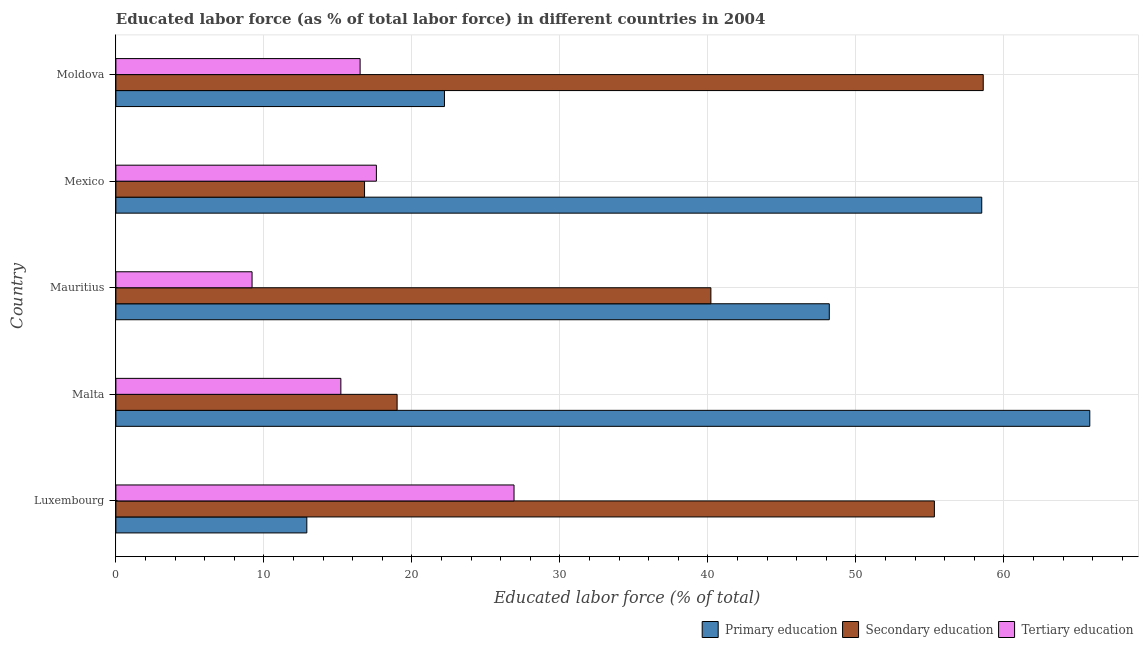How many different coloured bars are there?
Your answer should be very brief. 3. How many groups of bars are there?
Make the answer very short. 5. Are the number of bars per tick equal to the number of legend labels?
Your answer should be compact. Yes. Are the number of bars on each tick of the Y-axis equal?
Your answer should be compact. Yes. How many bars are there on the 4th tick from the top?
Keep it short and to the point. 3. What is the label of the 1st group of bars from the top?
Provide a succinct answer. Moldova. In how many cases, is the number of bars for a given country not equal to the number of legend labels?
Offer a terse response. 0. What is the percentage of labor force who received primary education in Luxembourg?
Offer a very short reply. 12.9. Across all countries, what is the maximum percentage of labor force who received tertiary education?
Offer a very short reply. 26.9. Across all countries, what is the minimum percentage of labor force who received secondary education?
Make the answer very short. 16.8. In which country was the percentage of labor force who received primary education maximum?
Provide a short and direct response. Malta. In which country was the percentage of labor force who received secondary education minimum?
Offer a very short reply. Mexico. What is the total percentage of labor force who received tertiary education in the graph?
Your answer should be very brief. 85.4. What is the difference between the percentage of labor force who received primary education in Mexico and that in Moldova?
Your answer should be very brief. 36.3. What is the difference between the percentage of labor force who received primary education in Moldova and the percentage of labor force who received tertiary education in Malta?
Your answer should be compact. 7. What is the average percentage of labor force who received secondary education per country?
Give a very brief answer. 37.98. In how many countries, is the percentage of labor force who received secondary education greater than 6 %?
Provide a succinct answer. 5. What is the ratio of the percentage of labor force who received secondary education in Malta to that in Mauritius?
Offer a terse response. 0.47. Is the difference between the percentage of labor force who received secondary education in Luxembourg and Malta greater than the difference between the percentage of labor force who received primary education in Luxembourg and Malta?
Ensure brevity in your answer.  Yes. What is the difference between the highest and the second highest percentage of labor force who received primary education?
Ensure brevity in your answer.  7.3. What is the difference between the highest and the lowest percentage of labor force who received primary education?
Give a very brief answer. 52.9. What does the 1st bar from the top in Mauritius represents?
Your answer should be compact. Tertiary education. What does the 3rd bar from the bottom in Mauritius represents?
Offer a terse response. Tertiary education. Are all the bars in the graph horizontal?
Offer a terse response. Yes. Are the values on the major ticks of X-axis written in scientific E-notation?
Offer a terse response. No. Does the graph contain any zero values?
Ensure brevity in your answer.  No. How many legend labels are there?
Ensure brevity in your answer.  3. What is the title of the graph?
Your response must be concise. Educated labor force (as % of total labor force) in different countries in 2004. What is the label or title of the X-axis?
Make the answer very short. Educated labor force (% of total). What is the Educated labor force (% of total) in Primary education in Luxembourg?
Offer a terse response. 12.9. What is the Educated labor force (% of total) in Secondary education in Luxembourg?
Offer a very short reply. 55.3. What is the Educated labor force (% of total) of Tertiary education in Luxembourg?
Offer a very short reply. 26.9. What is the Educated labor force (% of total) of Primary education in Malta?
Keep it short and to the point. 65.8. What is the Educated labor force (% of total) in Secondary education in Malta?
Your answer should be compact. 19. What is the Educated labor force (% of total) of Tertiary education in Malta?
Provide a succinct answer. 15.2. What is the Educated labor force (% of total) in Primary education in Mauritius?
Offer a terse response. 48.2. What is the Educated labor force (% of total) in Secondary education in Mauritius?
Provide a short and direct response. 40.2. What is the Educated labor force (% of total) in Tertiary education in Mauritius?
Keep it short and to the point. 9.2. What is the Educated labor force (% of total) in Primary education in Mexico?
Your response must be concise. 58.5. What is the Educated labor force (% of total) in Secondary education in Mexico?
Provide a succinct answer. 16.8. What is the Educated labor force (% of total) in Tertiary education in Mexico?
Your response must be concise. 17.6. What is the Educated labor force (% of total) of Primary education in Moldova?
Your answer should be very brief. 22.2. What is the Educated labor force (% of total) of Secondary education in Moldova?
Ensure brevity in your answer.  58.6. What is the Educated labor force (% of total) of Tertiary education in Moldova?
Provide a short and direct response. 16.5. Across all countries, what is the maximum Educated labor force (% of total) of Primary education?
Make the answer very short. 65.8. Across all countries, what is the maximum Educated labor force (% of total) in Secondary education?
Keep it short and to the point. 58.6. Across all countries, what is the maximum Educated labor force (% of total) in Tertiary education?
Keep it short and to the point. 26.9. Across all countries, what is the minimum Educated labor force (% of total) of Primary education?
Provide a short and direct response. 12.9. Across all countries, what is the minimum Educated labor force (% of total) in Secondary education?
Your answer should be very brief. 16.8. Across all countries, what is the minimum Educated labor force (% of total) in Tertiary education?
Provide a succinct answer. 9.2. What is the total Educated labor force (% of total) of Primary education in the graph?
Offer a very short reply. 207.6. What is the total Educated labor force (% of total) of Secondary education in the graph?
Offer a very short reply. 189.9. What is the total Educated labor force (% of total) of Tertiary education in the graph?
Give a very brief answer. 85.4. What is the difference between the Educated labor force (% of total) of Primary education in Luxembourg and that in Malta?
Give a very brief answer. -52.9. What is the difference between the Educated labor force (% of total) of Secondary education in Luxembourg and that in Malta?
Offer a terse response. 36.3. What is the difference between the Educated labor force (% of total) in Primary education in Luxembourg and that in Mauritius?
Offer a very short reply. -35.3. What is the difference between the Educated labor force (% of total) in Primary education in Luxembourg and that in Mexico?
Your answer should be very brief. -45.6. What is the difference between the Educated labor force (% of total) of Secondary education in Luxembourg and that in Mexico?
Make the answer very short. 38.5. What is the difference between the Educated labor force (% of total) in Tertiary education in Luxembourg and that in Mexico?
Provide a short and direct response. 9.3. What is the difference between the Educated labor force (% of total) of Secondary education in Luxembourg and that in Moldova?
Offer a terse response. -3.3. What is the difference between the Educated labor force (% of total) in Secondary education in Malta and that in Mauritius?
Your answer should be compact. -21.2. What is the difference between the Educated labor force (% of total) in Primary education in Malta and that in Mexico?
Keep it short and to the point. 7.3. What is the difference between the Educated labor force (% of total) in Primary education in Malta and that in Moldova?
Make the answer very short. 43.6. What is the difference between the Educated labor force (% of total) in Secondary education in Malta and that in Moldova?
Provide a short and direct response. -39.6. What is the difference between the Educated labor force (% of total) in Primary education in Mauritius and that in Mexico?
Provide a succinct answer. -10.3. What is the difference between the Educated labor force (% of total) of Secondary education in Mauritius and that in Mexico?
Your answer should be very brief. 23.4. What is the difference between the Educated labor force (% of total) in Tertiary education in Mauritius and that in Mexico?
Your response must be concise. -8.4. What is the difference between the Educated labor force (% of total) in Primary education in Mauritius and that in Moldova?
Provide a succinct answer. 26. What is the difference between the Educated labor force (% of total) of Secondary education in Mauritius and that in Moldova?
Ensure brevity in your answer.  -18.4. What is the difference between the Educated labor force (% of total) of Primary education in Mexico and that in Moldova?
Provide a succinct answer. 36.3. What is the difference between the Educated labor force (% of total) in Secondary education in Mexico and that in Moldova?
Your response must be concise. -41.8. What is the difference between the Educated labor force (% of total) of Primary education in Luxembourg and the Educated labor force (% of total) of Secondary education in Malta?
Provide a short and direct response. -6.1. What is the difference between the Educated labor force (% of total) in Secondary education in Luxembourg and the Educated labor force (% of total) in Tertiary education in Malta?
Give a very brief answer. 40.1. What is the difference between the Educated labor force (% of total) of Primary education in Luxembourg and the Educated labor force (% of total) of Secondary education in Mauritius?
Provide a short and direct response. -27.3. What is the difference between the Educated labor force (% of total) of Primary education in Luxembourg and the Educated labor force (% of total) of Tertiary education in Mauritius?
Ensure brevity in your answer.  3.7. What is the difference between the Educated labor force (% of total) of Secondary education in Luxembourg and the Educated labor force (% of total) of Tertiary education in Mauritius?
Keep it short and to the point. 46.1. What is the difference between the Educated labor force (% of total) in Primary education in Luxembourg and the Educated labor force (% of total) in Secondary education in Mexico?
Your response must be concise. -3.9. What is the difference between the Educated labor force (% of total) in Secondary education in Luxembourg and the Educated labor force (% of total) in Tertiary education in Mexico?
Provide a succinct answer. 37.7. What is the difference between the Educated labor force (% of total) in Primary education in Luxembourg and the Educated labor force (% of total) in Secondary education in Moldova?
Keep it short and to the point. -45.7. What is the difference between the Educated labor force (% of total) of Secondary education in Luxembourg and the Educated labor force (% of total) of Tertiary education in Moldova?
Keep it short and to the point. 38.8. What is the difference between the Educated labor force (% of total) of Primary education in Malta and the Educated labor force (% of total) of Secondary education in Mauritius?
Your answer should be compact. 25.6. What is the difference between the Educated labor force (% of total) in Primary education in Malta and the Educated labor force (% of total) in Tertiary education in Mauritius?
Your answer should be compact. 56.6. What is the difference between the Educated labor force (% of total) in Primary education in Malta and the Educated labor force (% of total) in Secondary education in Mexico?
Offer a very short reply. 49. What is the difference between the Educated labor force (% of total) of Primary education in Malta and the Educated labor force (% of total) of Tertiary education in Mexico?
Keep it short and to the point. 48.2. What is the difference between the Educated labor force (% of total) of Primary education in Malta and the Educated labor force (% of total) of Tertiary education in Moldova?
Your answer should be compact. 49.3. What is the difference between the Educated labor force (% of total) of Primary education in Mauritius and the Educated labor force (% of total) of Secondary education in Mexico?
Give a very brief answer. 31.4. What is the difference between the Educated labor force (% of total) in Primary education in Mauritius and the Educated labor force (% of total) in Tertiary education in Mexico?
Your response must be concise. 30.6. What is the difference between the Educated labor force (% of total) of Secondary education in Mauritius and the Educated labor force (% of total) of Tertiary education in Mexico?
Your answer should be very brief. 22.6. What is the difference between the Educated labor force (% of total) in Primary education in Mauritius and the Educated labor force (% of total) in Tertiary education in Moldova?
Provide a short and direct response. 31.7. What is the difference between the Educated labor force (% of total) of Secondary education in Mauritius and the Educated labor force (% of total) of Tertiary education in Moldova?
Offer a very short reply. 23.7. What is the difference between the Educated labor force (% of total) in Primary education in Mexico and the Educated labor force (% of total) in Tertiary education in Moldova?
Make the answer very short. 42. What is the average Educated labor force (% of total) of Primary education per country?
Offer a very short reply. 41.52. What is the average Educated labor force (% of total) of Secondary education per country?
Your answer should be compact. 37.98. What is the average Educated labor force (% of total) in Tertiary education per country?
Provide a short and direct response. 17.08. What is the difference between the Educated labor force (% of total) of Primary education and Educated labor force (% of total) of Secondary education in Luxembourg?
Your response must be concise. -42.4. What is the difference between the Educated labor force (% of total) of Secondary education and Educated labor force (% of total) of Tertiary education in Luxembourg?
Keep it short and to the point. 28.4. What is the difference between the Educated labor force (% of total) of Primary education and Educated labor force (% of total) of Secondary education in Malta?
Your answer should be compact. 46.8. What is the difference between the Educated labor force (% of total) in Primary education and Educated labor force (% of total) in Tertiary education in Malta?
Your answer should be compact. 50.6. What is the difference between the Educated labor force (% of total) of Secondary education and Educated labor force (% of total) of Tertiary education in Malta?
Provide a succinct answer. 3.8. What is the difference between the Educated labor force (% of total) in Primary education and Educated labor force (% of total) in Secondary education in Mexico?
Provide a short and direct response. 41.7. What is the difference between the Educated labor force (% of total) of Primary education and Educated labor force (% of total) of Tertiary education in Mexico?
Provide a succinct answer. 40.9. What is the difference between the Educated labor force (% of total) in Primary education and Educated labor force (% of total) in Secondary education in Moldova?
Give a very brief answer. -36.4. What is the difference between the Educated labor force (% of total) of Primary education and Educated labor force (% of total) of Tertiary education in Moldova?
Keep it short and to the point. 5.7. What is the difference between the Educated labor force (% of total) of Secondary education and Educated labor force (% of total) of Tertiary education in Moldova?
Give a very brief answer. 42.1. What is the ratio of the Educated labor force (% of total) of Primary education in Luxembourg to that in Malta?
Provide a succinct answer. 0.2. What is the ratio of the Educated labor force (% of total) in Secondary education in Luxembourg to that in Malta?
Your answer should be compact. 2.91. What is the ratio of the Educated labor force (% of total) of Tertiary education in Luxembourg to that in Malta?
Ensure brevity in your answer.  1.77. What is the ratio of the Educated labor force (% of total) in Primary education in Luxembourg to that in Mauritius?
Offer a terse response. 0.27. What is the ratio of the Educated labor force (% of total) of Secondary education in Luxembourg to that in Mauritius?
Your answer should be compact. 1.38. What is the ratio of the Educated labor force (% of total) in Tertiary education in Luxembourg to that in Mauritius?
Your answer should be very brief. 2.92. What is the ratio of the Educated labor force (% of total) in Primary education in Luxembourg to that in Mexico?
Offer a terse response. 0.22. What is the ratio of the Educated labor force (% of total) in Secondary education in Luxembourg to that in Mexico?
Provide a succinct answer. 3.29. What is the ratio of the Educated labor force (% of total) in Tertiary education in Luxembourg to that in Mexico?
Offer a terse response. 1.53. What is the ratio of the Educated labor force (% of total) in Primary education in Luxembourg to that in Moldova?
Provide a succinct answer. 0.58. What is the ratio of the Educated labor force (% of total) of Secondary education in Luxembourg to that in Moldova?
Your answer should be compact. 0.94. What is the ratio of the Educated labor force (% of total) in Tertiary education in Luxembourg to that in Moldova?
Your answer should be compact. 1.63. What is the ratio of the Educated labor force (% of total) in Primary education in Malta to that in Mauritius?
Offer a terse response. 1.37. What is the ratio of the Educated labor force (% of total) in Secondary education in Malta to that in Mauritius?
Ensure brevity in your answer.  0.47. What is the ratio of the Educated labor force (% of total) in Tertiary education in Malta to that in Mauritius?
Provide a short and direct response. 1.65. What is the ratio of the Educated labor force (% of total) of Primary education in Malta to that in Mexico?
Keep it short and to the point. 1.12. What is the ratio of the Educated labor force (% of total) of Secondary education in Malta to that in Mexico?
Your answer should be very brief. 1.13. What is the ratio of the Educated labor force (% of total) in Tertiary education in Malta to that in Mexico?
Your answer should be very brief. 0.86. What is the ratio of the Educated labor force (% of total) of Primary education in Malta to that in Moldova?
Your answer should be compact. 2.96. What is the ratio of the Educated labor force (% of total) of Secondary education in Malta to that in Moldova?
Your answer should be very brief. 0.32. What is the ratio of the Educated labor force (% of total) of Tertiary education in Malta to that in Moldova?
Provide a short and direct response. 0.92. What is the ratio of the Educated labor force (% of total) of Primary education in Mauritius to that in Mexico?
Give a very brief answer. 0.82. What is the ratio of the Educated labor force (% of total) in Secondary education in Mauritius to that in Mexico?
Your answer should be very brief. 2.39. What is the ratio of the Educated labor force (% of total) of Tertiary education in Mauritius to that in Mexico?
Your answer should be very brief. 0.52. What is the ratio of the Educated labor force (% of total) in Primary education in Mauritius to that in Moldova?
Give a very brief answer. 2.17. What is the ratio of the Educated labor force (% of total) in Secondary education in Mauritius to that in Moldova?
Your answer should be compact. 0.69. What is the ratio of the Educated labor force (% of total) in Tertiary education in Mauritius to that in Moldova?
Give a very brief answer. 0.56. What is the ratio of the Educated labor force (% of total) in Primary education in Mexico to that in Moldova?
Offer a very short reply. 2.64. What is the ratio of the Educated labor force (% of total) of Secondary education in Mexico to that in Moldova?
Provide a short and direct response. 0.29. What is the ratio of the Educated labor force (% of total) of Tertiary education in Mexico to that in Moldova?
Ensure brevity in your answer.  1.07. What is the difference between the highest and the second highest Educated labor force (% of total) in Secondary education?
Your response must be concise. 3.3. What is the difference between the highest and the second highest Educated labor force (% of total) of Tertiary education?
Provide a succinct answer. 9.3. What is the difference between the highest and the lowest Educated labor force (% of total) in Primary education?
Offer a terse response. 52.9. What is the difference between the highest and the lowest Educated labor force (% of total) in Secondary education?
Keep it short and to the point. 41.8. 